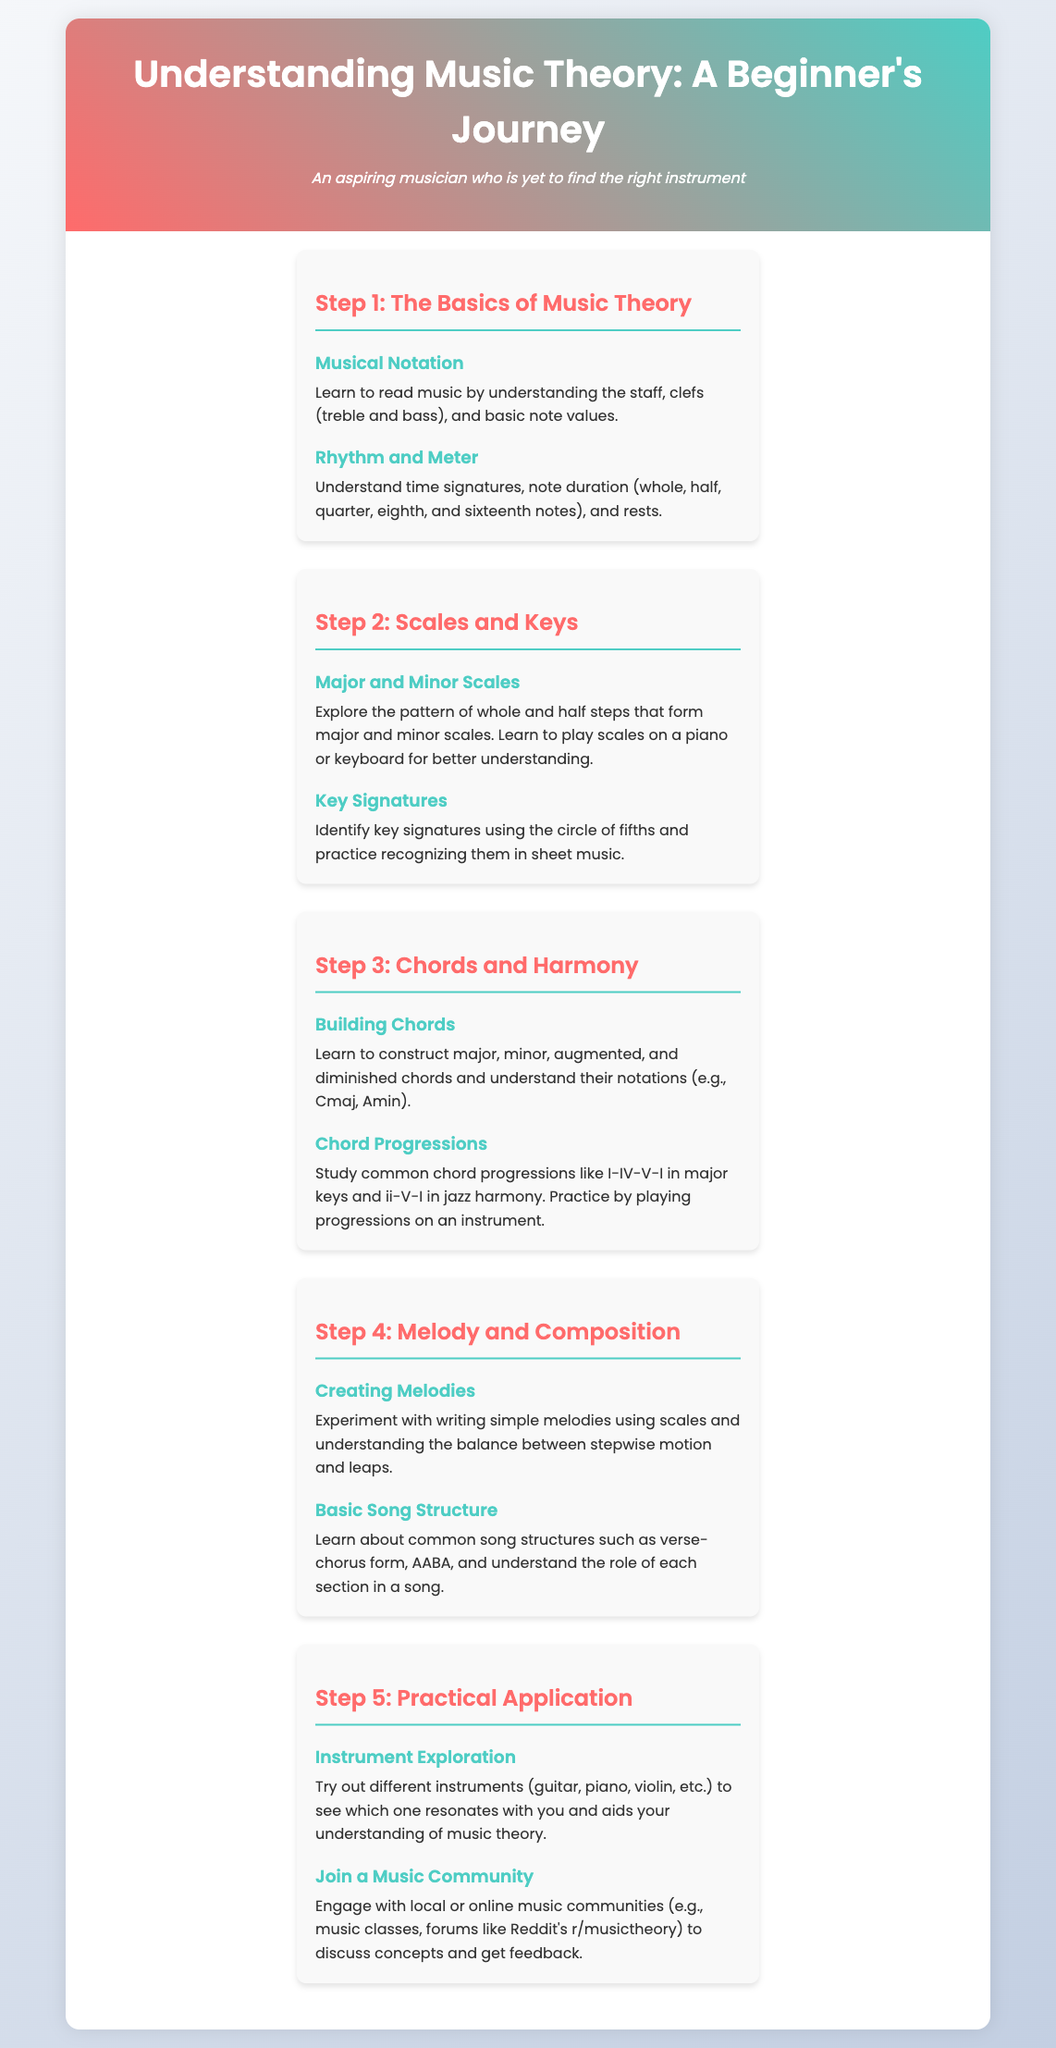What is the first step in the journey? The first step outlined in the infographic is "The Basics of Music Theory."
Answer: The Basics of Music Theory What are the two types of scales mentioned? The infographic refers to major and minor scales as key elements in Step 2.
Answer: Major and Minor Scales What chord types are introduced in Step 3? The document lists major, minor, augmented, and diminished chords as types learned in Step 3.
Answer: Major, minor, augmented, and diminished chords What is the common chord progression in major keys mentioned? The infographic identifies the I-IV-V-I progression as common in major keys.
Answer: I-IV-V-I Which two activities are suggested in Step 5 for practical application? The infographic recommends exploring different instruments and joining a music community as activities in Step 5.
Answer: Instrument Exploration and Join a Music Community What is emphasized in the Creating Melodies section? The section on creating melodies discusses experimenting with writing simple melodies.
Answer: Writing simple melodies What concept does "Key Signatures" relate to? The idea of key signatures is related to the use and identification of the circle of fifths as mentioned in Step 2.
Answer: Circle of fifths In which step are common song structures discussed? Common song structures are discussed in Step 4 of the document.
Answer: Step 4 What should you try according to the Instrument Exploration section? The document suggests trying out different instruments like guitar, piano, and violin.
Answer: Different instruments (guitar, piano, violin, etc.) 